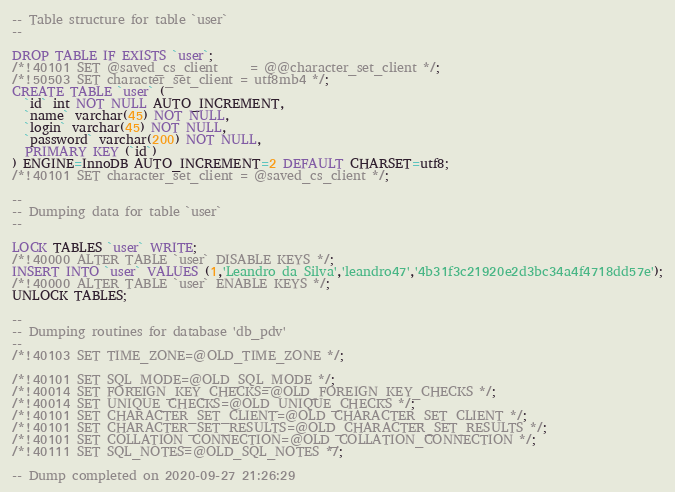Convert code to text. <code><loc_0><loc_0><loc_500><loc_500><_SQL_>-- Table structure for table `user`
--

DROP TABLE IF EXISTS `user`;
/*!40101 SET @saved_cs_client     = @@character_set_client */;
/*!50503 SET character_set_client = utf8mb4 */;
CREATE TABLE `user` (
  `id` int NOT NULL AUTO_INCREMENT,
  `name` varchar(45) NOT NULL,
  `login` varchar(45) NOT NULL,
  `password` varchar(200) NOT NULL,
  PRIMARY KEY (`id`)
) ENGINE=InnoDB AUTO_INCREMENT=2 DEFAULT CHARSET=utf8;
/*!40101 SET character_set_client = @saved_cs_client */;

--
-- Dumping data for table `user`
--

LOCK TABLES `user` WRITE;
/*!40000 ALTER TABLE `user` DISABLE KEYS */;
INSERT INTO `user` VALUES (1,'Leandro da Silva','leandro47','4b31f3c21920e2d3bc34a4f4718dd57e');
/*!40000 ALTER TABLE `user` ENABLE KEYS */;
UNLOCK TABLES;

--
-- Dumping routines for database 'db_pdv'
--
/*!40103 SET TIME_ZONE=@OLD_TIME_ZONE */;

/*!40101 SET SQL_MODE=@OLD_SQL_MODE */;
/*!40014 SET FOREIGN_KEY_CHECKS=@OLD_FOREIGN_KEY_CHECKS */;
/*!40014 SET UNIQUE_CHECKS=@OLD_UNIQUE_CHECKS */;
/*!40101 SET CHARACTER_SET_CLIENT=@OLD_CHARACTER_SET_CLIENT */;
/*!40101 SET CHARACTER_SET_RESULTS=@OLD_CHARACTER_SET_RESULTS */;
/*!40101 SET COLLATION_CONNECTION=@OLD_COLLATION_CONNECTION */;
/*!40111 SET SQL_NOTES=@OLD_SQL_NOTES */;

-- Dump completed on 2020-09-27 21:26:29
</code> 